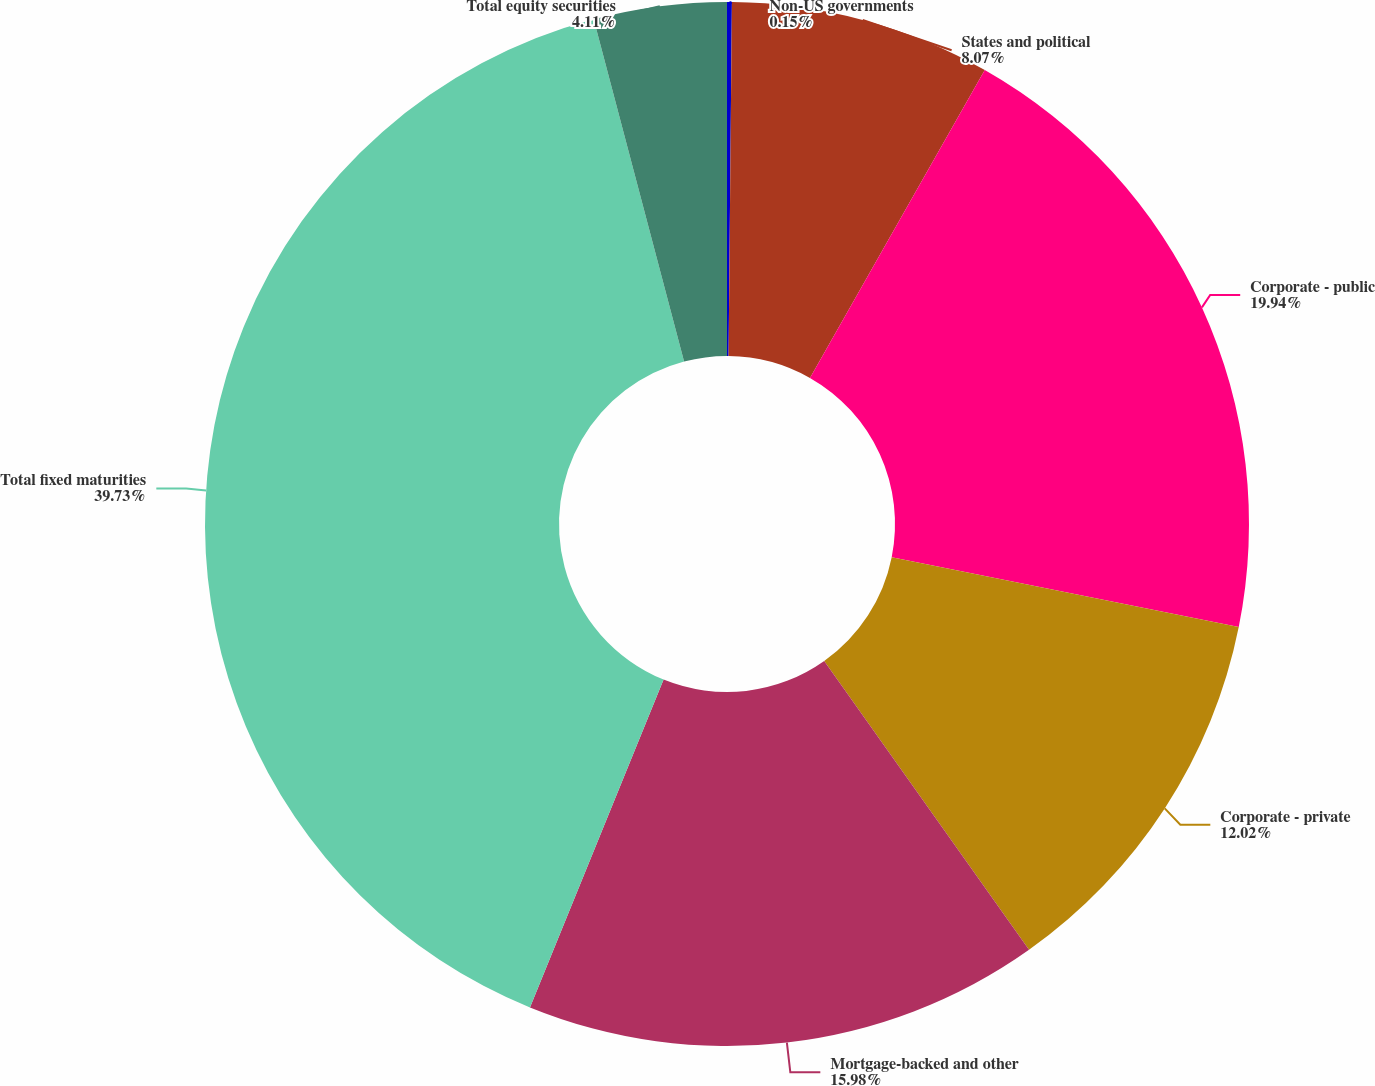Convert chart to OTSL. <chart><loc_0><loc_0><loc_500><loc_500><pie_chart><fcel>Non-US governments<fcel>States and political<fcel>Corporate - public<fcel>Corporate - private<fcel>Mortgage-backed and other<fcel>Total fixed maturities<fcel>Total equity securities<nl><fcel>0.15%<fcel>8.07%<fcel>19.94%<fcel>12.02%<fcel>15.98%<fcel>39.73%<fcel>4.11%<nl></chart> 